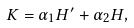<formula> <loc_0><loc_0><loc_500><loc_500>K = \alpha _ { 1 } H ^ { \prime } + \alpha _ { 2 } H ,</formula> 